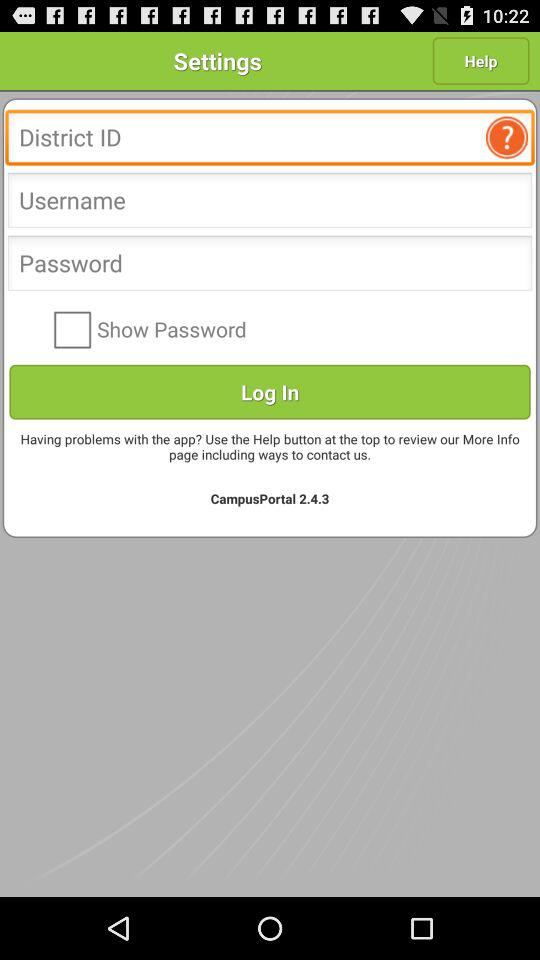What is the version of the app? The version is 2.4.3. 